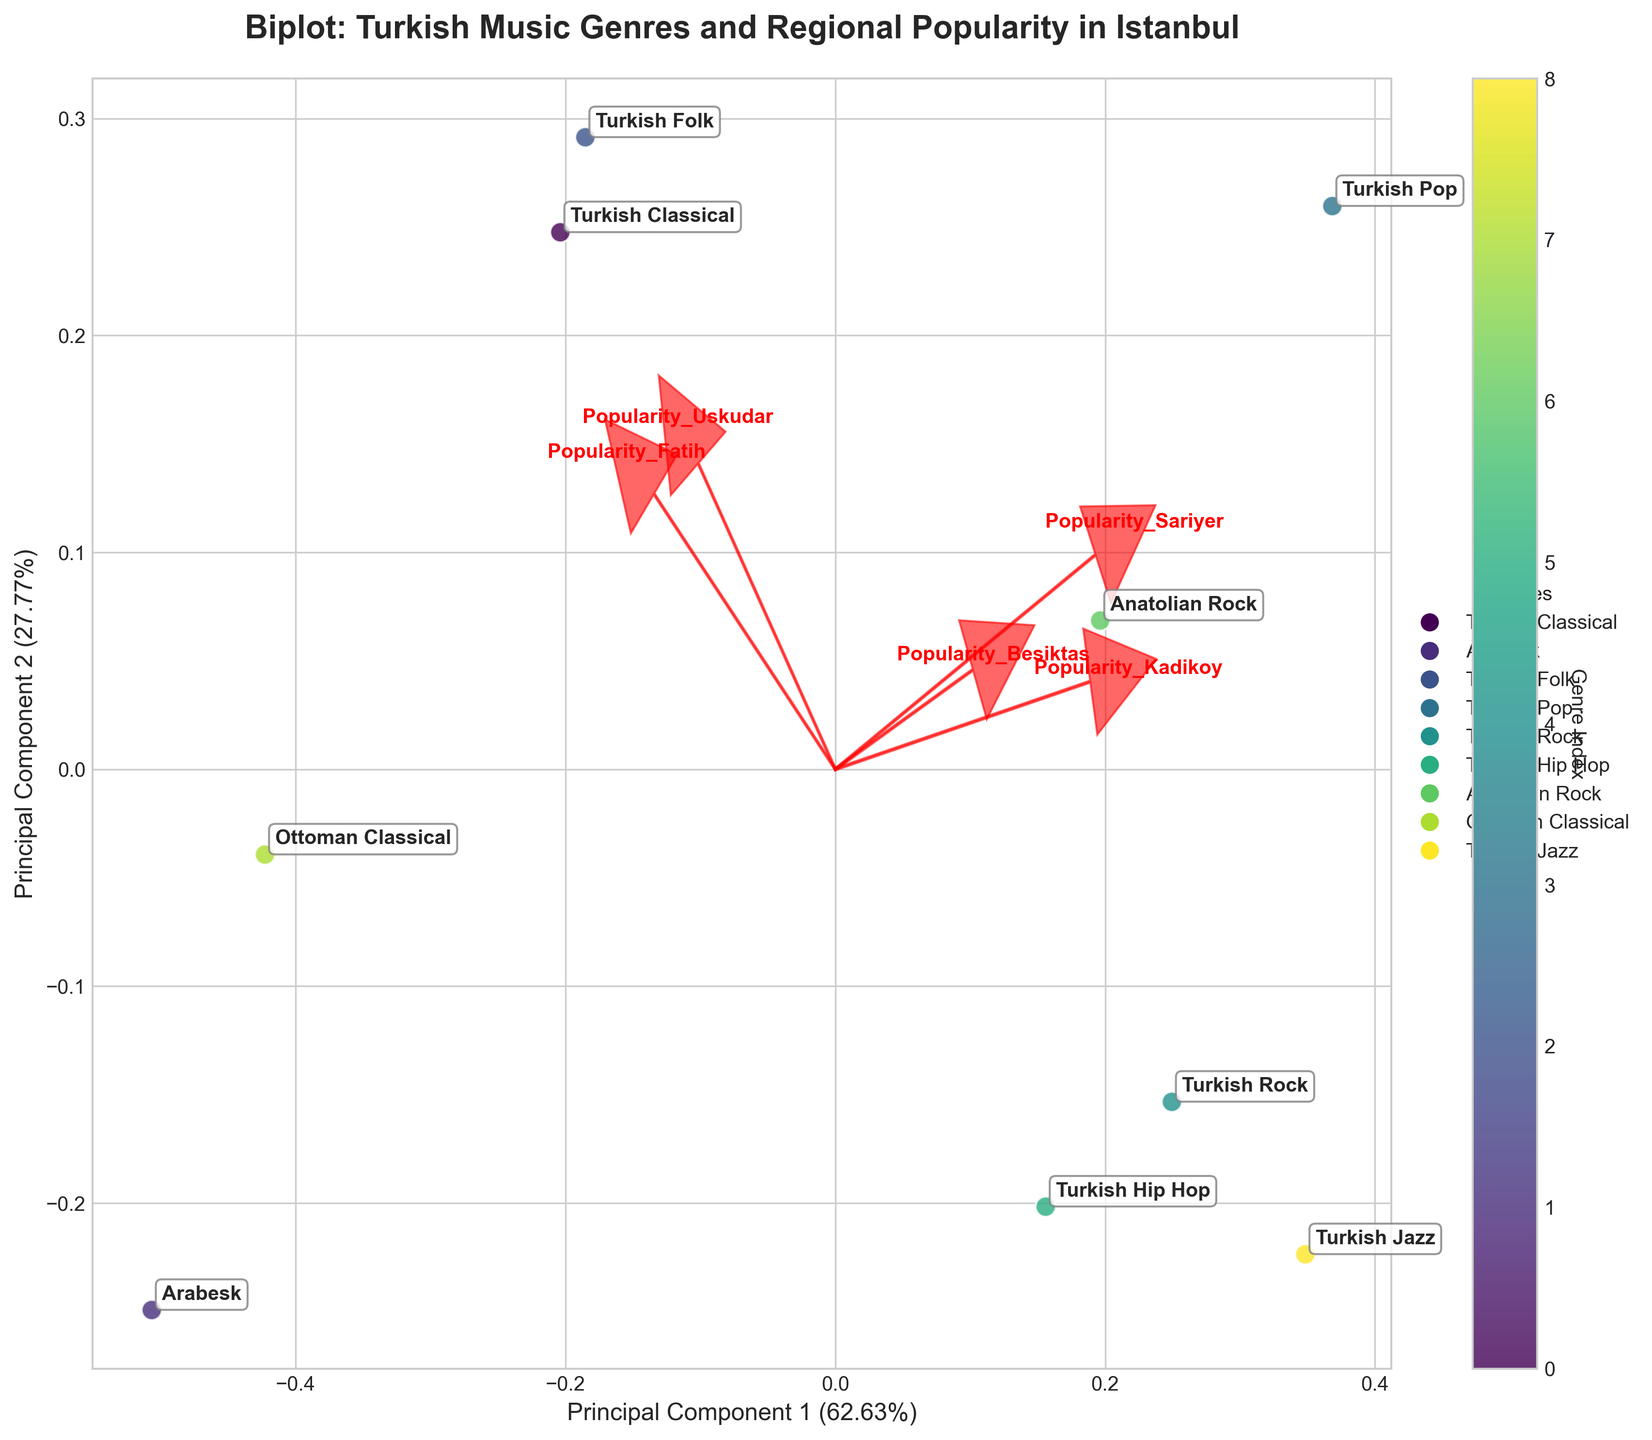What is the title of the biplot? The title of the figure is displayed at the top and it is written in a bold font. The title is "Biplot: Turkish Music Genres and Regional Popularity in Istanbul"
Answer: Biplot: Turkish Music Genres and Regional Popularity in Istanbul Which genre is represented by the point closest to the origin? By inspecting the scatter plot at the origin, we see that the genre closest to the origin (0,0) is "Anatolian Rock"
Answer: Anatolian Rock What are the two principal components represented on the axes? The x-axis and y-axis represent the two principal components identified through PCA. The x-axis represents Principal Component 1, while the y-axis represents Principal Component 2
Answer: Principal Component 1 and Principal Component 2 Which district has the highest influence on Principal Component 1? The loading vector with the largest magnitude in the x-direction (Principal Component 1) shows the district with the highest influence. Inspecting the red arrows, "Kadikoy" has the largest arrow pointing to the right
Answer: Kadikoy Which genres are most similar in terms of their regional popularity? Genres close to each other in the plot have similar regional popularity patterns. "Turkish Classical" and "Turkish Folk" are closely situated
Answer: Turkish Classical and Turkish Folk Which genre has the most balanced popularity across all districts? The genre closest to the origin indicates balanced popularity across all districts. This is "Anatolian Rock" as it is closest to the origin
Answer: Anatolian Rock Which district has the lowest influence on Principal Component 2? The loading vector with the smallest magnitude in the y-direction (Principal Component 2) indicates the district with the lowest influence. "Uskudar" appears visually to have the smaller y-component compared to others
Answer: Uskudar What does the color bar next to the scatter plot represent? The color bar indicates the index of genres; they are mapped to different colors to assist in identifying them on the plot
Answer: Genre Index How much of the total variance is explained by the first two principal components combined? The axes labels contain the variance explained by each principal component. By adding PC1 and PC2, their combined variance is roughly 48.9% + 23.6%
Answer: 72.5% Which two genres are located farthest apart in the biplot? The maximum distance between two genres on the biplot shows the highest dissimilarity in regional popularity. "Turkish Jazz" and "Ottoman Classical" are located at opposite ends
Answer: Turkish Jazz and Ottoman Classical 